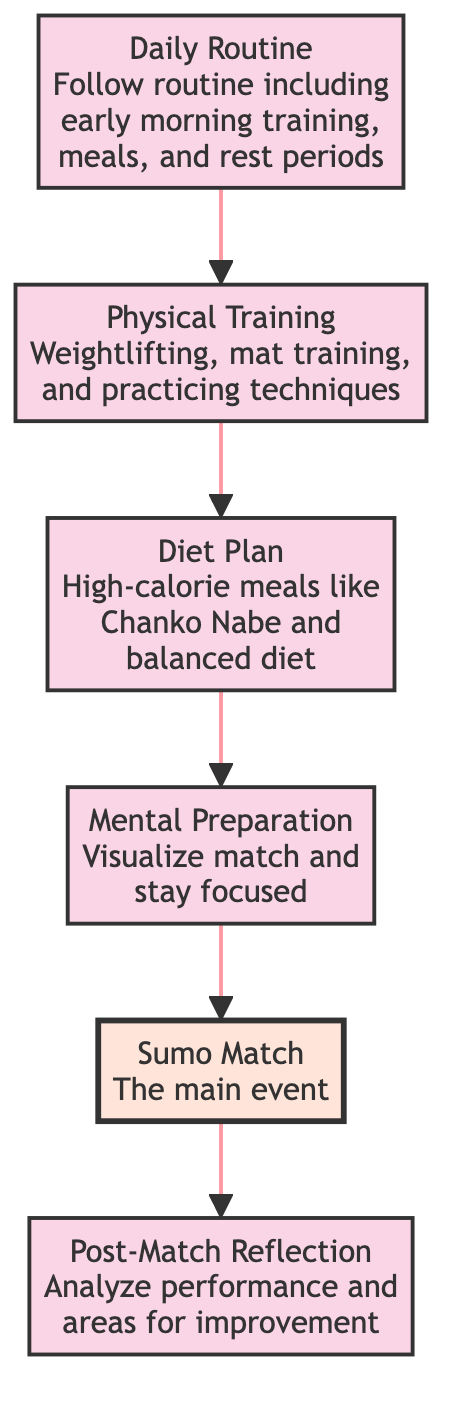What is the first step in the process? The first step in the diagram is "Daily Routine," which is indicated as the starting point on the flowchart.
Answer: Daily Routine How many processes are there in total? The diagram has five processes: "Daily Routine," "Physical Training," "Diet Plan," "Mental Preparation," and "Post-Match Reflection." These are all categories of activities described in the diagram.
Answer: Five What comes after "Physical Training"? According to the flow of the diagram, "Diet Plan" is the step that follows "Physical Training."
Answer: Diet Plan What type of node is "Sumo Match"? "Sumo Match" is classified as a terminal node in the diagram, which indicates it is an endpoint of the process flow.
Answer: Terminal What is included in the "Diet Plan"? The "Diet Plan" includes consuming high-calorie meals like Chanko Nabe as well as maintaining a balanced diet, as specified in the flowchart description.
Answer: High-calorie meals like Chanko Nabe Which step is directly linked to "Post-Match Reflection"? The step directly linked to "Post-Match Reflection" is "Sumo Match," as it follows the main event when the reflection occurs.
Answer: Sumo Match What is the sequence of steps leading to the match? The sequence of steps leading to "Sumo Match" is: "Daily Routine," then "Physical Training," followed by "Diet Plan," and then "Mental Preparation" before reaching the match.
Answer: Daily Routine → Physical Training → Diet Plan → Mental Preparation How does mental preparation relate to training? "Mental Preparation" follows after "Diet Plan," and indirectly relates to training as it occurs after physical exertion is considered, connecting the two by contributing to overall match readiness.
Answer: Follows after Diet Plan 